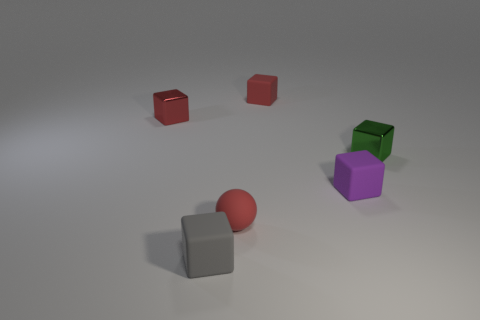What can you tell me about the distribution of colors among the objects? In the image, there is a variety of colored objects distributed across the frame. There are objects in red, cyan, purple, and green, as well as gray spheres. Each color is represented by a single object except for the color red, which appears twice in the form of two small cubes. 